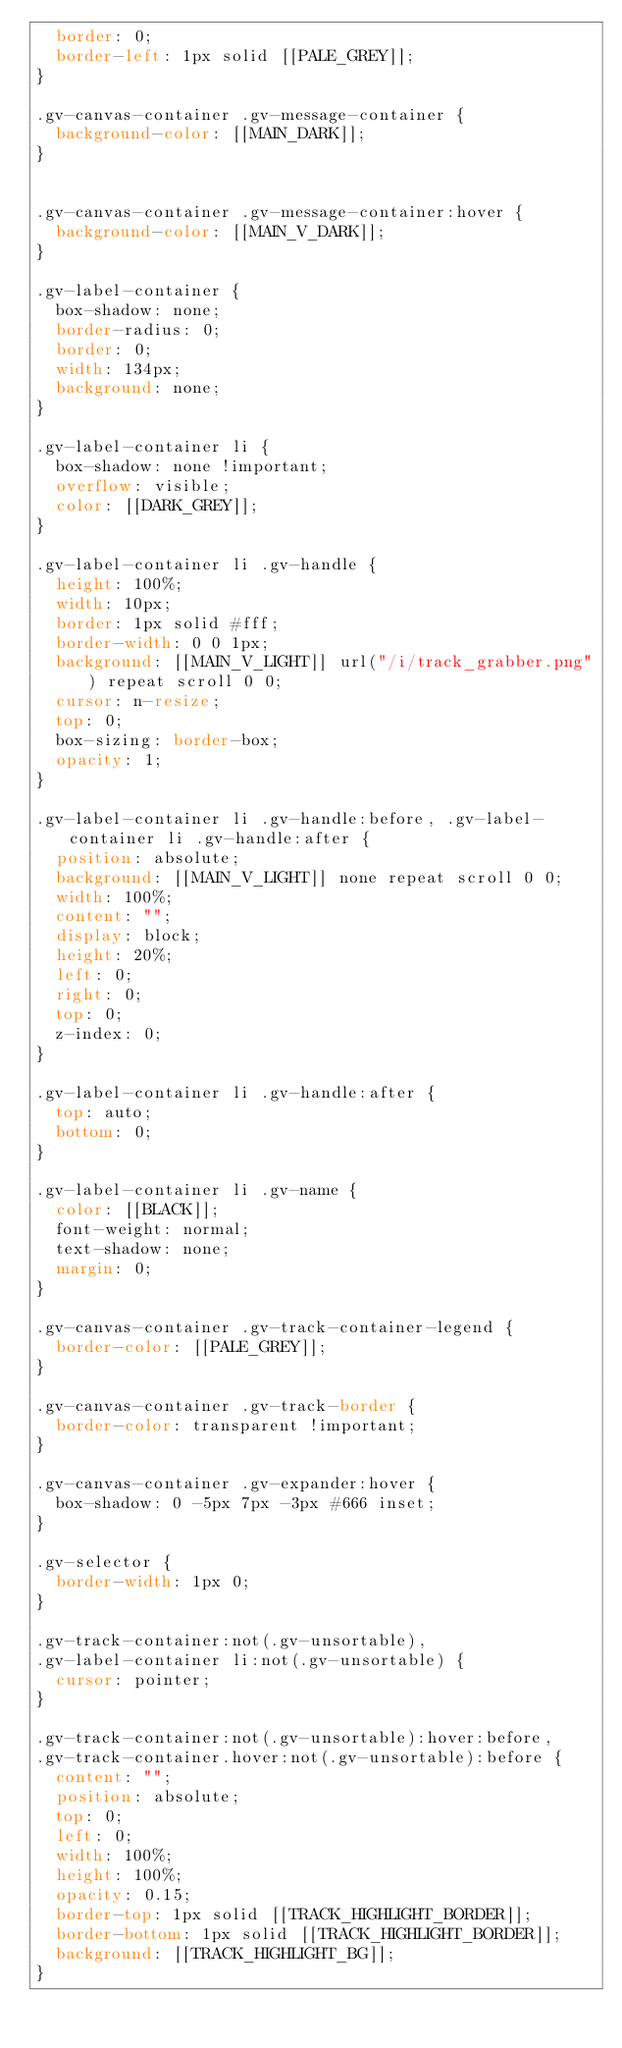Convert code to text. <code><loc_0><loc_0><loc_500><loc_500><_CSS_>  border: 0;
  border-left: 1px solid [[PALE_GREY]];
}

.gv-canvas-container .gv-message-container {
  background-color: [[MAIN_DARK]];
}


.gv-canvas-container .gv-message-container:hover {
  background-color: [[MAIN_V_DARK]];
}

.gv-label-container {
  box-shadow: none;
  border-radius: 0;
  border: 0;
  width: 134px;
  background: none;
}

.gv-label-container li {
  box-shadow: none !important;
  overflow: visible;
  color: [[DARK_GREY]];
}

.gv-label-container li .gv-handle {
  height: 100%;
  width: 10px;
  border: 1px solid #fff;
  border-width: 0 0 1px;
  background: [[MAIN_V_LIGHT]] url("/i/track_grabber.png") repeat scroll 0 0;
  cursor: n-resize;
  top: 0;
  box-sizing: border-box;
  opacity: 1;
}

.gv-label-container li .gv-handle:before, .gv-label-container li .gv-handle:after {
  position: absolute;
  background: [[MAIN_V_LIGHT]] none repeat scroll 0 0;
  width: 100%;
  content: "";
  display: block;
  height: 20%;
  left: 0;
  right: 0;
  top: 0;
  z-index: 0;
}

.gv-label-container li .gv-handle:after {
  top: auto;
  bottom: 0;
}

.gv-label-container li .gv-name {
  color: [[BLACK]];
  font-weight: normal;
  text-shadow: none;
  margin: 0;
}

.gv-canvas-container .gv-track-container-legend {
  border-color: [[PALE_GREY]];
}

.gv-canvas-container .gv-track-border {
  border-color: transparent !important;
}

.gv-canvas-container .gv-expander:hover {
  box-shadow: 0 -5px 7px -3px #666 inset;
}

.gv-selector {
  border-width: 1px 0;
}

.gv-track-container:not(.gv-unsortable),
.gv-label-container li:not(.gv-unsortable) {
  cursor: pointer;
}

.gv-track-container:not(.gv-unsortable):hover:before,
.gv-track-container.hover:not(.gv-unsortable):before {
  content: "";
  position: absolute;
  top: 0;
  left: 0;
  width: 100%;
  height: 100%;
  opacity: 0.15;
  border-top: 1px solid [[TRACK_HIGHLIGHT_BORDER]];
  border-bottom: 1px solid [[TRACK_HIGHLIGHT_BORDER]];
  background: [[TRACK_HIGHLIGHT_BG]];
}

</code> 